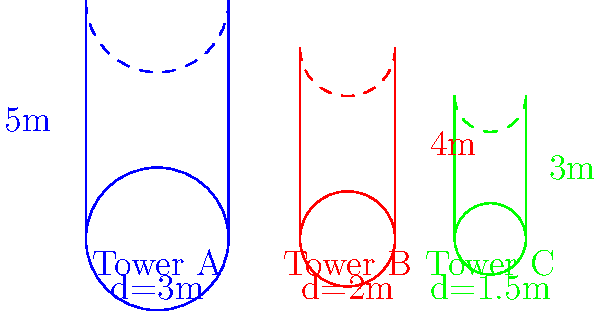As an IT manager overseeing network infrastructure, you need to calculate the total surface area of three cylindrical network towers for a potential outsourcing project. The towers have varying heights and diameters as shown in the diagram. Tower A has a height of 5m and a diameter of 3m, Tower B has a height of 4m and a diameter of 2m, and Tower C has a height of 3m and a diameter of 1.5m. Calculate the total surface area of all three towers combined, including their circular tops and bottoms. Round your answer to the nearest square meter. To calculate the total surface area of the cylindrical towers, we need to follow these steps for each tower:

1. Calculate the lateral surface area (side of the cylinder): $A_{lateral} = \pi dh$
2. Calculate the area of the circular top and bottom: $A_{circle} = \pi r^2 = \pi (d/2)^2$
3. Sum the lateral area and twice the circular area (top and bottom): $A_{total} = A_{lateral} + 2A_{circle}$

Let's calculate for each tower:

Tower A (height = 5m, diameter = 3m):
$A_{lateral} = \pi \cdot 3 \cdot 5 = 15\pi$
$A_{circle} = \pi (3/2)^2 = 2.25\pi$
$A_{total} = 15\pi + 2(2.25\pi) = 19.5\pi$

Tower B (height = 4m, diameter = 2m):
$A_{lateral} = \pi \cdot 2 \cdot 4 = 8\pi$
$A_{circle} = \pi (2/2)^2 = \pi$
$A_{total} = 8\pi + 2(\pi) = 10\pi$

Tower C (height = 3m, diameter = 1.5m):
$A_{lateral} = \pi \cdot 1.5 \cdot 3 = 4.5\pi$
$A_{circle} = \pi (1.5/2)^2 = 0.5625\pi$
$A_{total} = 4.5\pi + 2(0.5625\pi) = 5.625\pi$

Total surface area of all towers:
$A_{total} = 19.5\pi + 10\pi + 5.625\pi = 35.125\pi$

Converting to square meters:
$35.125\pi \approx 110.35$ square meters

Rounding to the nearest square meter: 110 square meters.
Answer: 110 square meters 